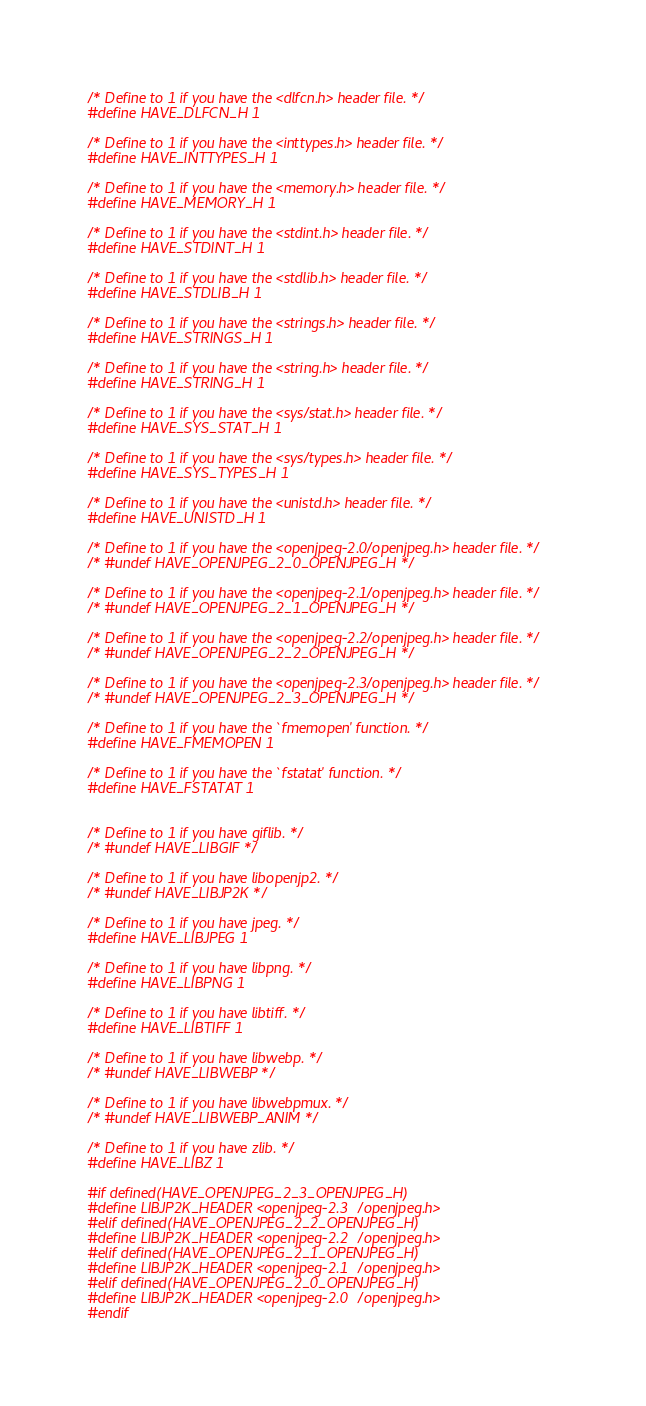Convert code to text. <code><loc_0><loc_0><loc_500><loc_500><_C_>/* Define to 1 if you have the <dlfcn.h> header file. */
#define HAVE_DLFCN_H 1

/* Define to 1 if you have the <inttypes.h> header file. */
#define HAVE_INTTYPES_H 1

/* Define to 1 if you have the <memory.h> header file. */
#define HAVE_MEMORY_H 1

/* Define to 1 if you have the <stdint.h> header file. */
#define HAVE_STDINT_H 1

/* Define to 1 if you have the <stdlib.h> header file. */
#define HAVE_STDLIB_H 1

/* Define to 1 if you have the <strings.h> header file. */
#define HAVE_STRINGS_H 1

/* Define to 1 if you have the <string.h> header file. */
#define HAVE_STRING_H 1

/* Define to 1 if you have the <sys/stat.h> header file. */
#define HAVE_SYS_STAT_H 1

/* Define to 1 if you have the <sys/types.h> header file. */
#define HAVE_SYS_TYPES_H 1

/* Define to 1 if you have the <unistd.h> header file. */
#define HAVE_UNISTD_H 1

/* Define to 1 if you have the <openjpeg-2.0/openjpeg.h> header file. */
/* #undef HAVE_OPENJPEG_2_0_OPENJPEG_H */

/* Define to 1 if you have the <openjpeg-2.1/openjpeg.h> header file. */
/* #undef HAVE_OPENJPEG_2_1_OPENJPEG_H */

/* Define to 1 if you have the <openjpeg-2.2/openjpeg.h> header file. */
/* #undef HAVE_OPENJPEG_2_2_OPENJPEG_H */

/* Define to 1 if you have the <openjpeg-2.3/openjpeg.h> header file. */
/* #undef HAVE_OPENJPEG_2_3_OPENJPEG_H */

/* Define to 1 if you have the `fmemopen' function. */
#define HAVE_FMEMOPEN 1

/* Define to 1 if you have the `fstatat' function. */
#define HAVE_FSTATAT 1


/* Define to 1 if you have giflib. */
/* #undef HAVE_LIBGIF */

/* Define to 1 if you have libopenjp2. */
/* #undef HAVE_LIBJP2K */

/* Define to 1 if you have jpeg. */
#define HAVE_LIBJPEG 1

/* Define to 1 if you have libpng. */
#define HAVE_LIBPNG 1

/* Define to 1 if you have libtiff. */
#define HAVE_LIBTIFF 1

/* Define to 1 if you have libwebp. */
/* #undef HAVE_LIBWEBP */

/* Define to 1 if you have libwebpmux. */
/* #undef HAVE_LIBWEBP_ANIM */

/* Define to 1 if you have zlib. */
#define HAVE_LIBZ 1

#if defined(HAVE_OPENJPEG_2_3_OPENJPEG_H)
#define LIBJP2K_HEADER <openjpeg-2.3/openjpeg.h>
#elif defined(HAVE_OPENJPEG_2_2_OPENJPEG_H)
#define LIBJP2K_HEADER <openjpeg-2.2/openjpeg.h>
#elif defined(HAVE_OPENJPEG_2_1_OPENJPEG_H)
#define LIBJP2K_HEADER <openjpeg-2.1/openjpeg.h>
#elif defined(HAVE_OPENJPEG_2_0_OPENJPEG_H)
#define LIBJP2K_HEADER <openjpeg-2.0/openjpeg.h>
#endif
</code> 